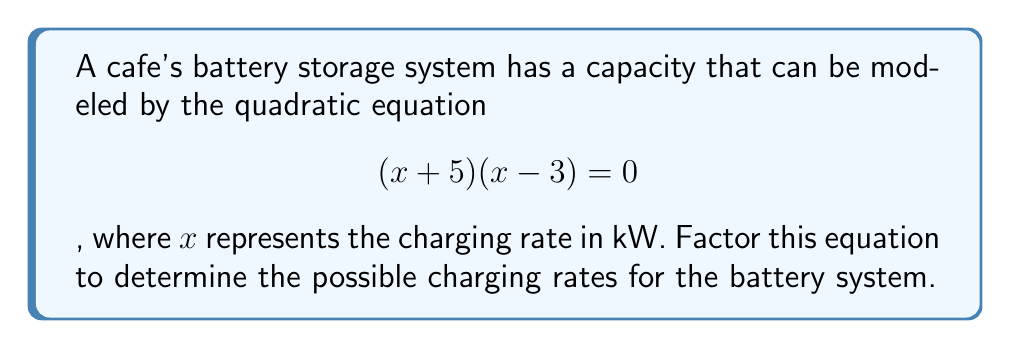Give your solution to this math problem. To factor this quadratic equation, we need to follow these steps:

1. Recognize that the equation is already in factored form: $(x+5)(x-3) = 0$

2. Apply the zero product property, which states that if the product of factors is zero, then one or more of the factors must be zero.

3. Set each factor equal to zero and solve for x:

   Factor 1: $x + 5 = 0$
             $x = -5$

   Factor 2: $x - 3 = 0$
             $x = 3$

4. The solutions represent the charging rates at which the battery capacity equation equals zero. These are the x-intercepts of the quadratic function and correspond to the possible charging rates for the battery system.

Therefore, the possible charging rates are -5 kW and 3 kW. However, since charging rates cannot be negative in practical applications, we can conclude that the only feasible charging rate for this battery system is 3 kW.
Answer: $x = -5$ or $x = 3$; practical solution: $x = 3$ kW 